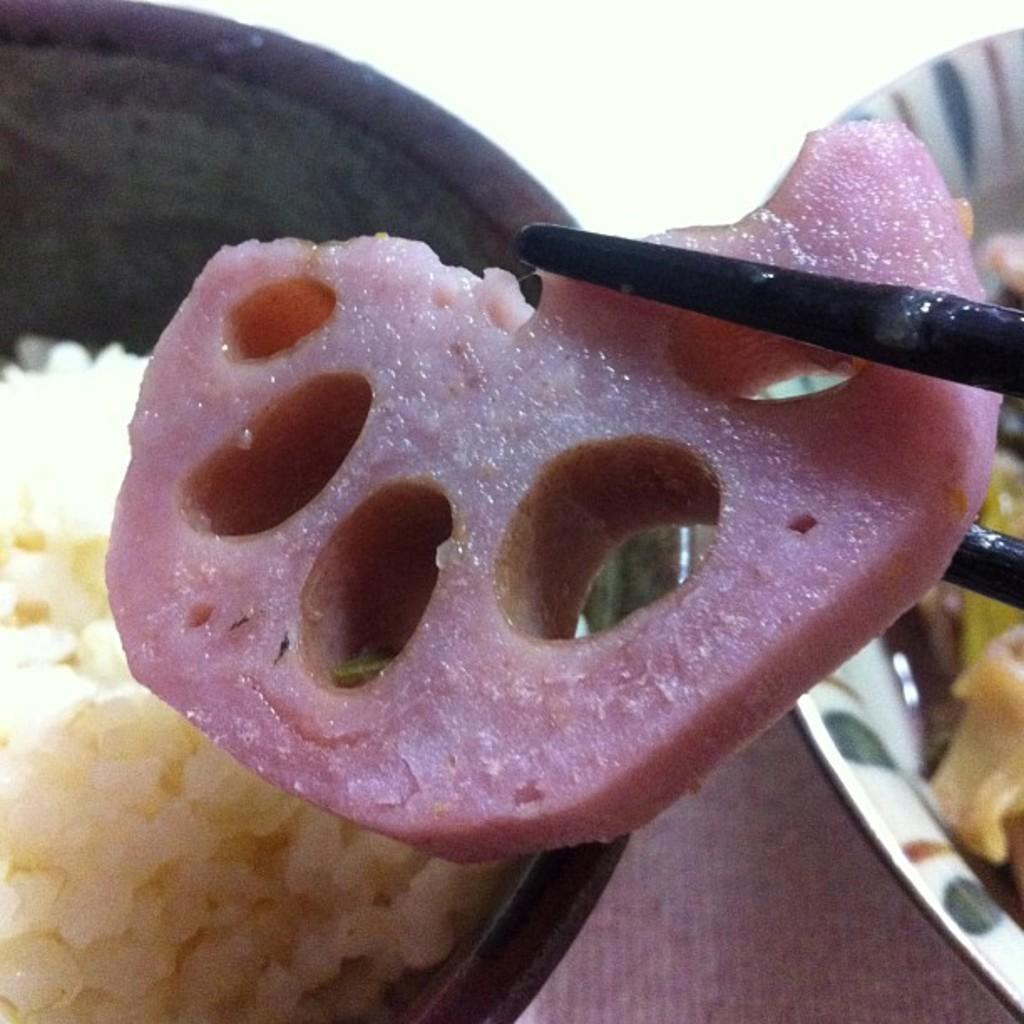Please provide a concise description of this image. In this picture I can see food in couple of bowls and I can see couple of chopsticks holding some food. 